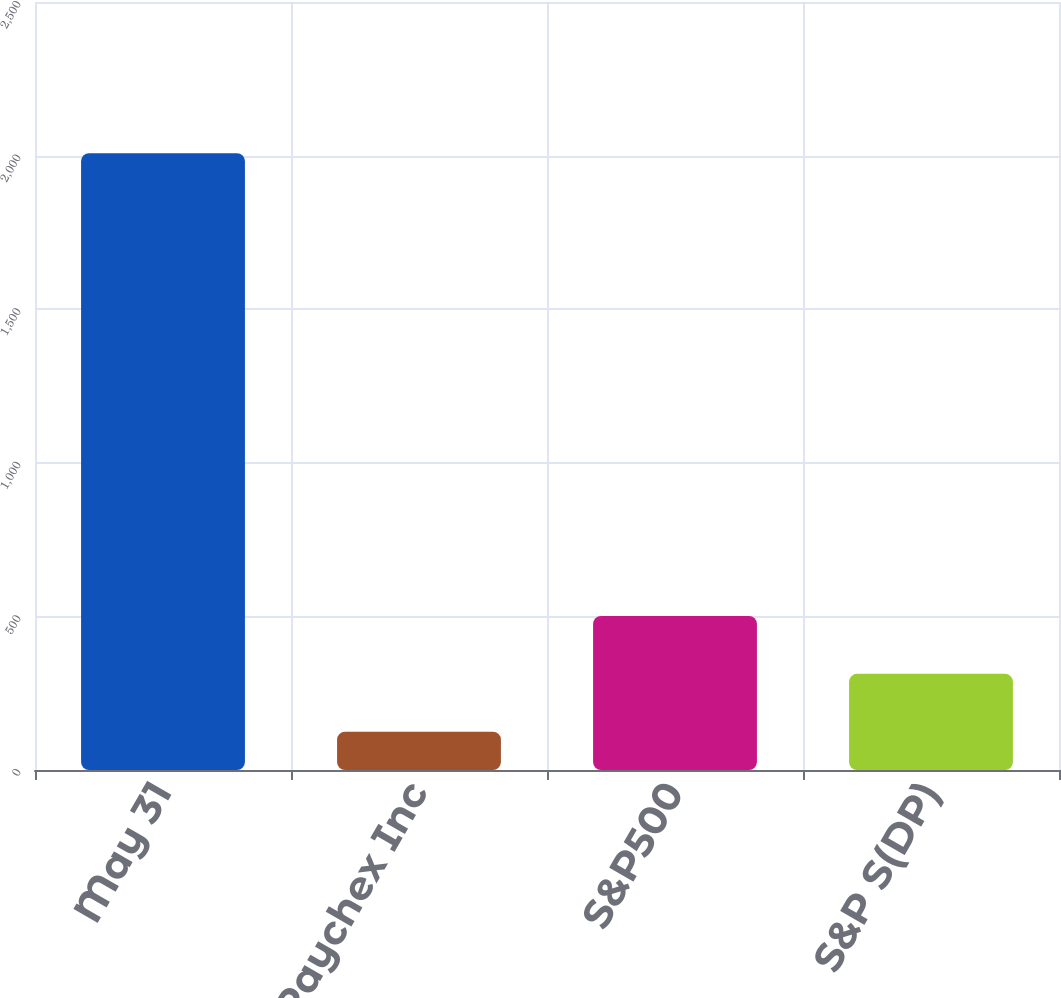<chart> <loc_0><loc_0><loc_500><loc_500><bar_chart><fcel>May 31<fcel>Paychex Inc<fcel>S&P500<fcel>S&P S(DP)<nl><fcel>2008<fcel>124.89<fcel>501.51<fcel>313.2<nl></chart> 